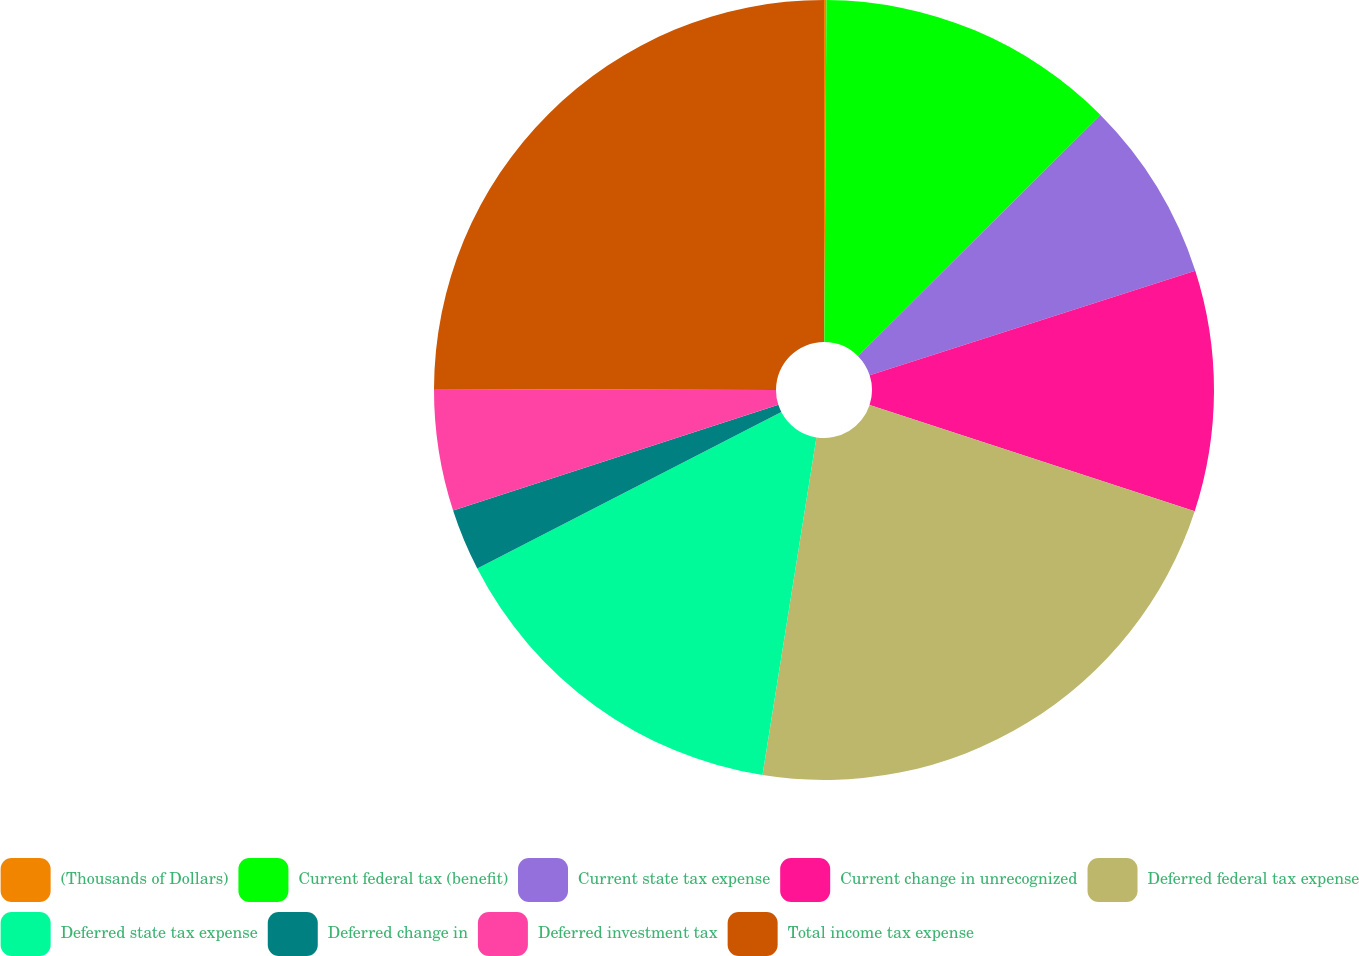Convert chart to OTSL. <chart><loc_0><loc_0><loc_500><loc_500><pie_chart><fcel>(Thousands of Dollars)<fcel>Current federal tax (benefit)<fcel>Current state tax expense<fcel>Current change in unrecognized<fcel>Deferred federal tax expense<fcel>Deferred state tax expense<fcel>Deferred change in<fcel>Deferred investment tax<fcel>Total income tax expense<nl><fcel>0.1%<fcel>12.44%<fcel>7.51%<fcel>9.98%<fcel>22.49%<fcel>14.91%<fcel>2.57%<fcel>5.04%<fcel>24.96%<nl></chart> 